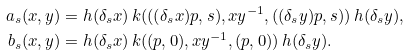<formula> <loc_0><loc_0><loc_500><loc_500>a _ { s } ( x , y ) & = h ( \delta _ { s } x ) \, k ( ( ( \delta _ { s } x ) p , s ) , x y ^ { - 1 } , ( ( \delta _ { s } y ) p , s ) ) \, h ( \delta _ { s } y ) , \\ b _ { s } ( x , y ) & = h ( \delta _ { s } x ) \, k ( ( p , 0 ) , x y ^ { - 1 } , ( p , 0 ) ) \, h ( \delta _ { s } y ) .</formula> 